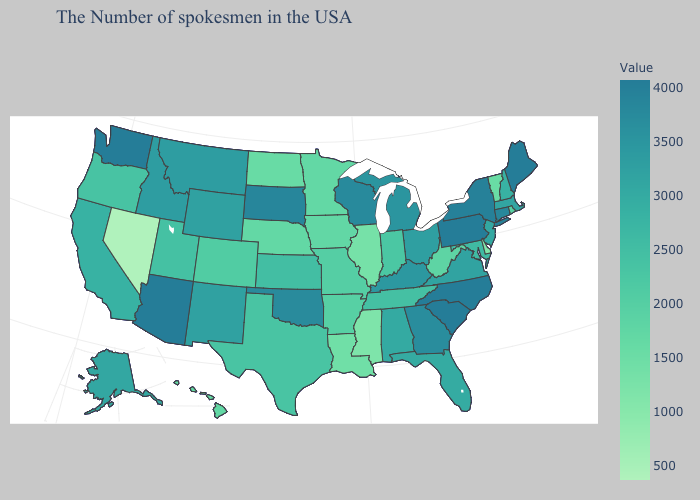Is the legend a continuous bar?
Be succinct. Yes. Among the states that border Colorado , which have the lowest value?
Give a very brief answer. Nebraska. Does Vermont have a lower value than Ohio?
Short answer required. Yes. Which states have the lowest value in the West?
Short answer required. Nevada. Which states have the lowest value in the USA?
Give a very brief answer. Nevada. 